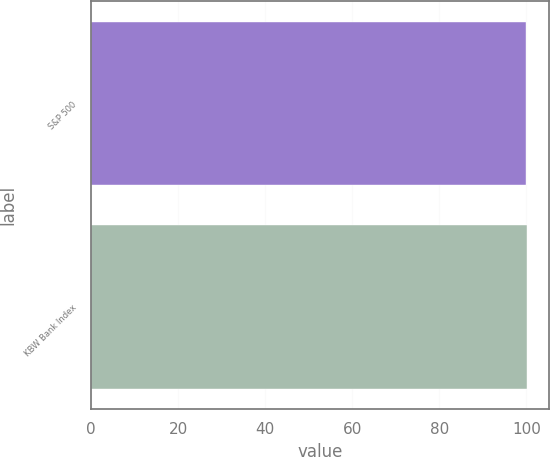<chart> <loc_0><loc_0><loc_500><loc_500><bar_chart><fcel>S&P 500<fcel>KBW Bank Index<nl><fcel>100<fcel>100.1<nl></chart> 